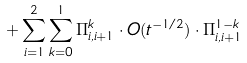<formula> <loc_0><loc_0><loc_500><loc_500>+ \sum _ { i = 1 } ^ { 2 } \sum _ { k = 0 } ^ { 1 } \Pi _ { i , i + 1 } ^ { k } \cdot O ( t ^ { - 1 / 2 } ) \cdot \Pi _ { i , i + 1 } ^ { 1 - k }</formula> 